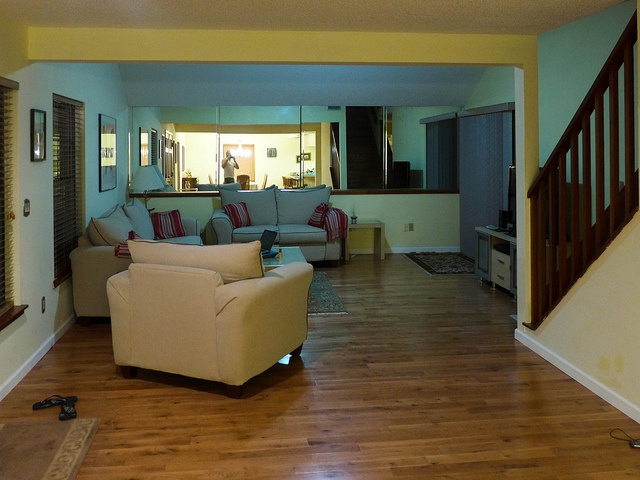Describe the objects in this image and their specific colors. I can see chair in olive and tan tones, couch in olive, teal, and black tones, couch in olive, teal, and black tones, tv in olive, black, and gray tones, and people in olive, tan, gray, and beige tones in this image. 